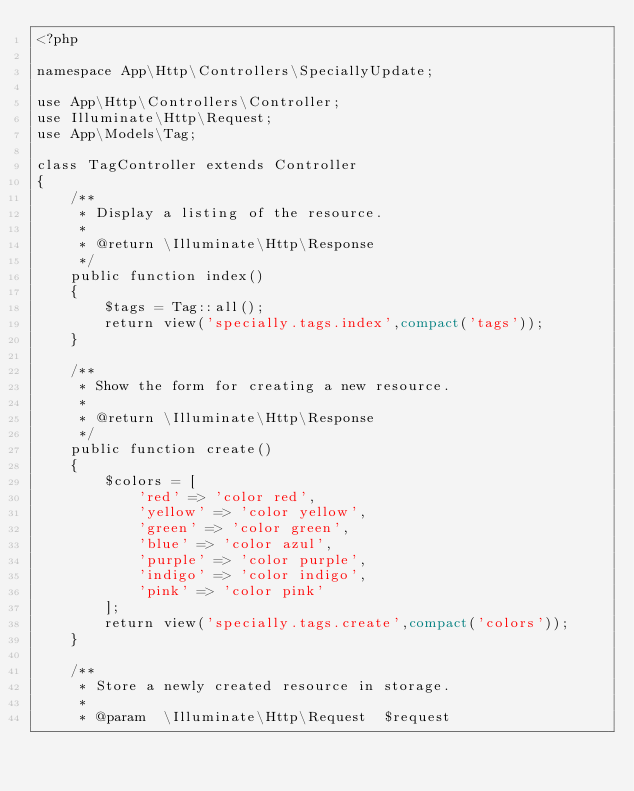Convert code to text. <code><loc_0><loc_0><loc_500><loc_500><_PHP_><?php

namespace App\Http\Controllers\SpeciallyUpdate;

use App\Http\Controllers\Controller;
use Illuminate\Http\Request;
use App\Models\Tag;

class TagController extends Controller
{
    /**
     * Display a listing of the resource.
     *
     * @return \Illuminate\Http\Response
     */
    public function index()
    {
        $tags = Tag::all();
        return view('specially.tags.index',compact('tags'));
    }

    /**
     * Show the form for creating a new resource.
     *
     * @return \Illuminate\Http\Response
     */
    public function create()
    {
        $colors = [
            'red' => 'color red',
            'yellow' => 'color yellow',
            'green' => 'color green',
            'blue' => 'color azul',
            'purple' => 'color purple',
            'indigo' => 'color indigo',
            'pink' => 'color pink'
        ];
        return view('specially.tags.create',compact('colors'));
    }

    /**
     * Store a newly created resource in storage.
     *
     * @param  \Illuminate\Http\Request  $request</code> 